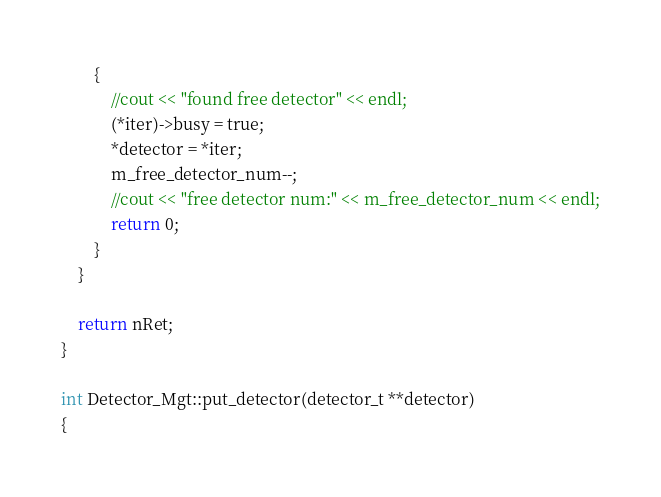<code> <loc_0><loc_0><loc_500><loc_500><_C++_>		{
			//cout << "found free detector" << endl;
			(*iter)->busy = true;
			*detector = *iter;
			m_free_detector_num--;
			//cout << "free detector num:" << m_free_detector_num << endl;
			return 0;
		}
	}

	return nRet;
}

int Detector_Mgt::put_detector(detector_t **detector)
{</code> 